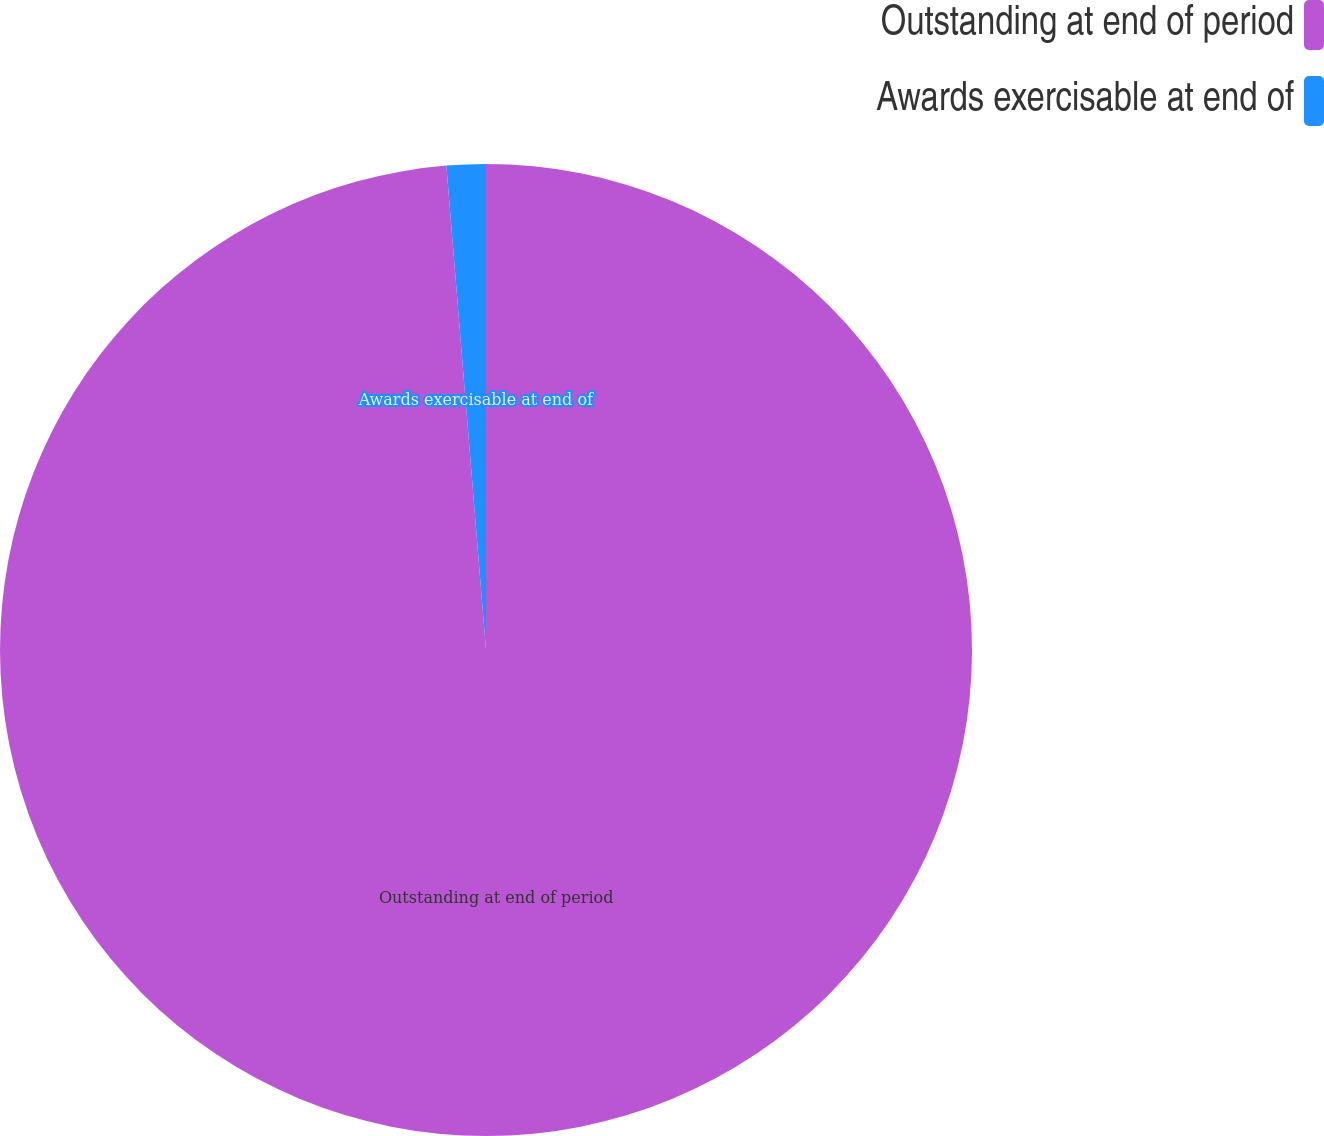<chart> <loc_0><loc_0><loc_500><loc_500><pie_chart><fcel>Outstanding at end of period<fcel>Awards exercisable at end of<nl><fcel>98.7%<fcel>1.3%<nl></chart> 